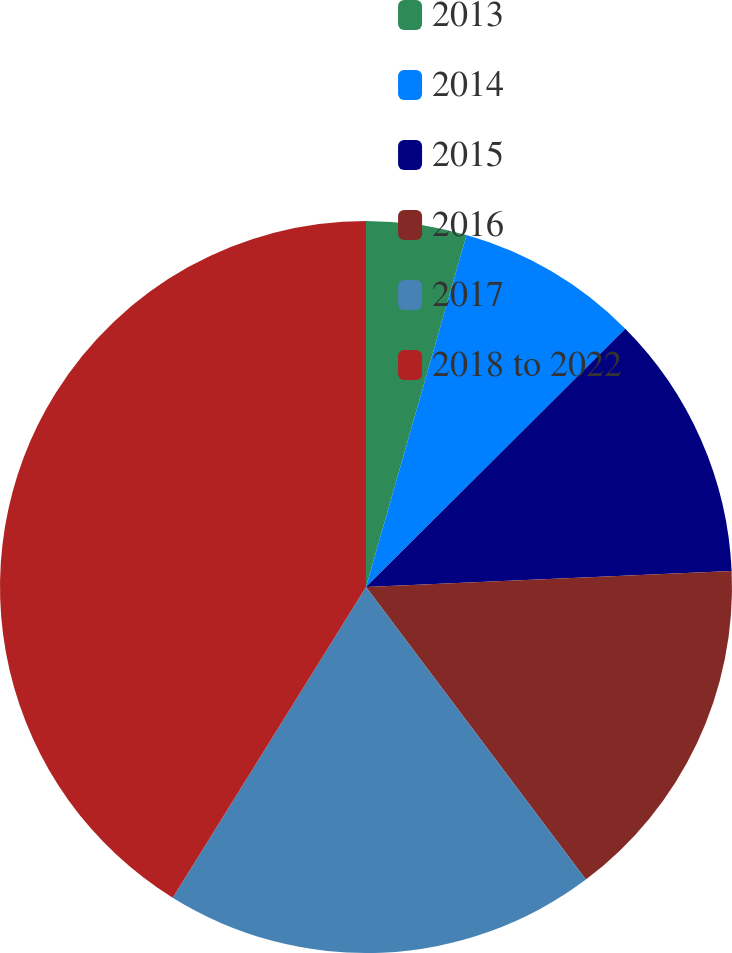Convert chart. <chart><loc_0><loc_0><loc_500><loc_500><pie_chart><fcel>2013<fcel>2014<fcel>2015<fcel>2016<fcel>2017<fcel>2018 to 2022<nl><fcel>4.43%<fcel>8.1%<fcel>11.77%<fcel>15.44%<fcel>19.11%<fcel>41.14%<nl></chart> 